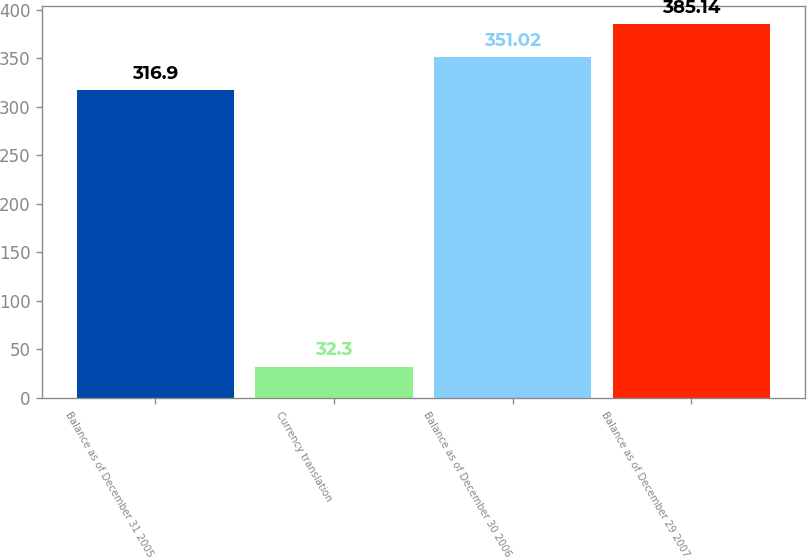<chart> <loc_0><loc_0><loc_500><loc_500><bar_chart><fcel>Balance as of December 31 2005<fcel>Currency translation<fcel>Balance as of December 30 2006<fcel>Balance as of December 29 2007<nl><fcel>316.9<fcel>32.3<fcel>351.02<fcel>385.14<nl></chart> 